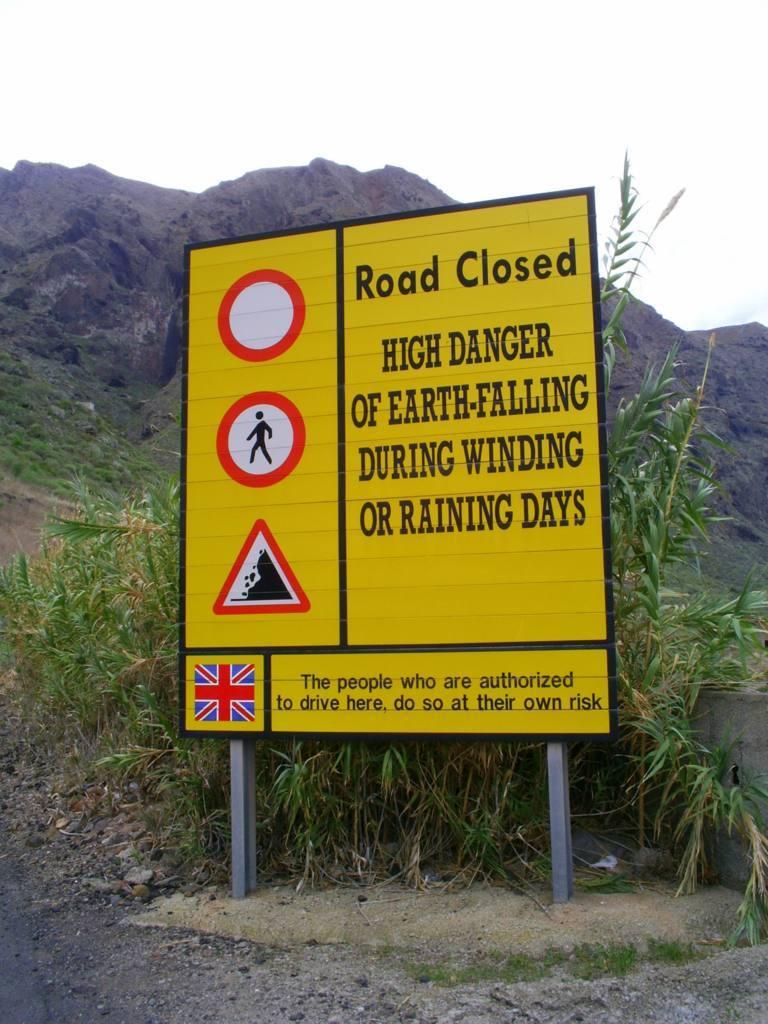What is there a high danger of?
Provide a short and direct response. Earth-falling. Is the road closed to all traffic here?
Your answer should be very brief. Yes. 